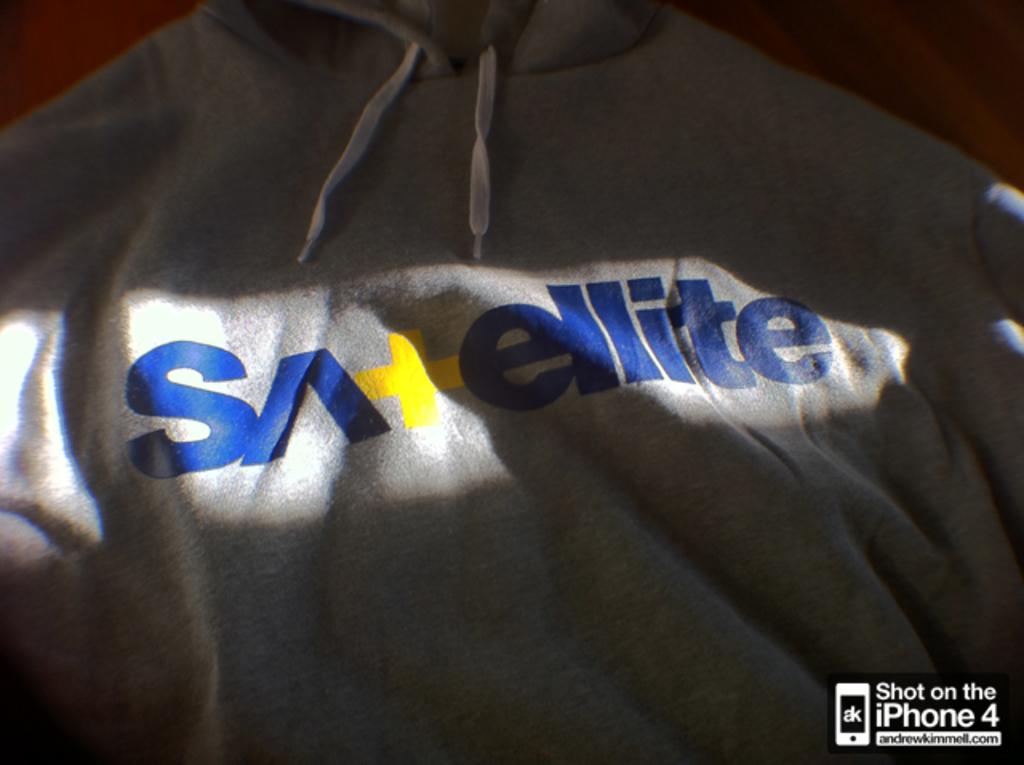Which letter is in yellow ?
Your answer should be compact. T. 